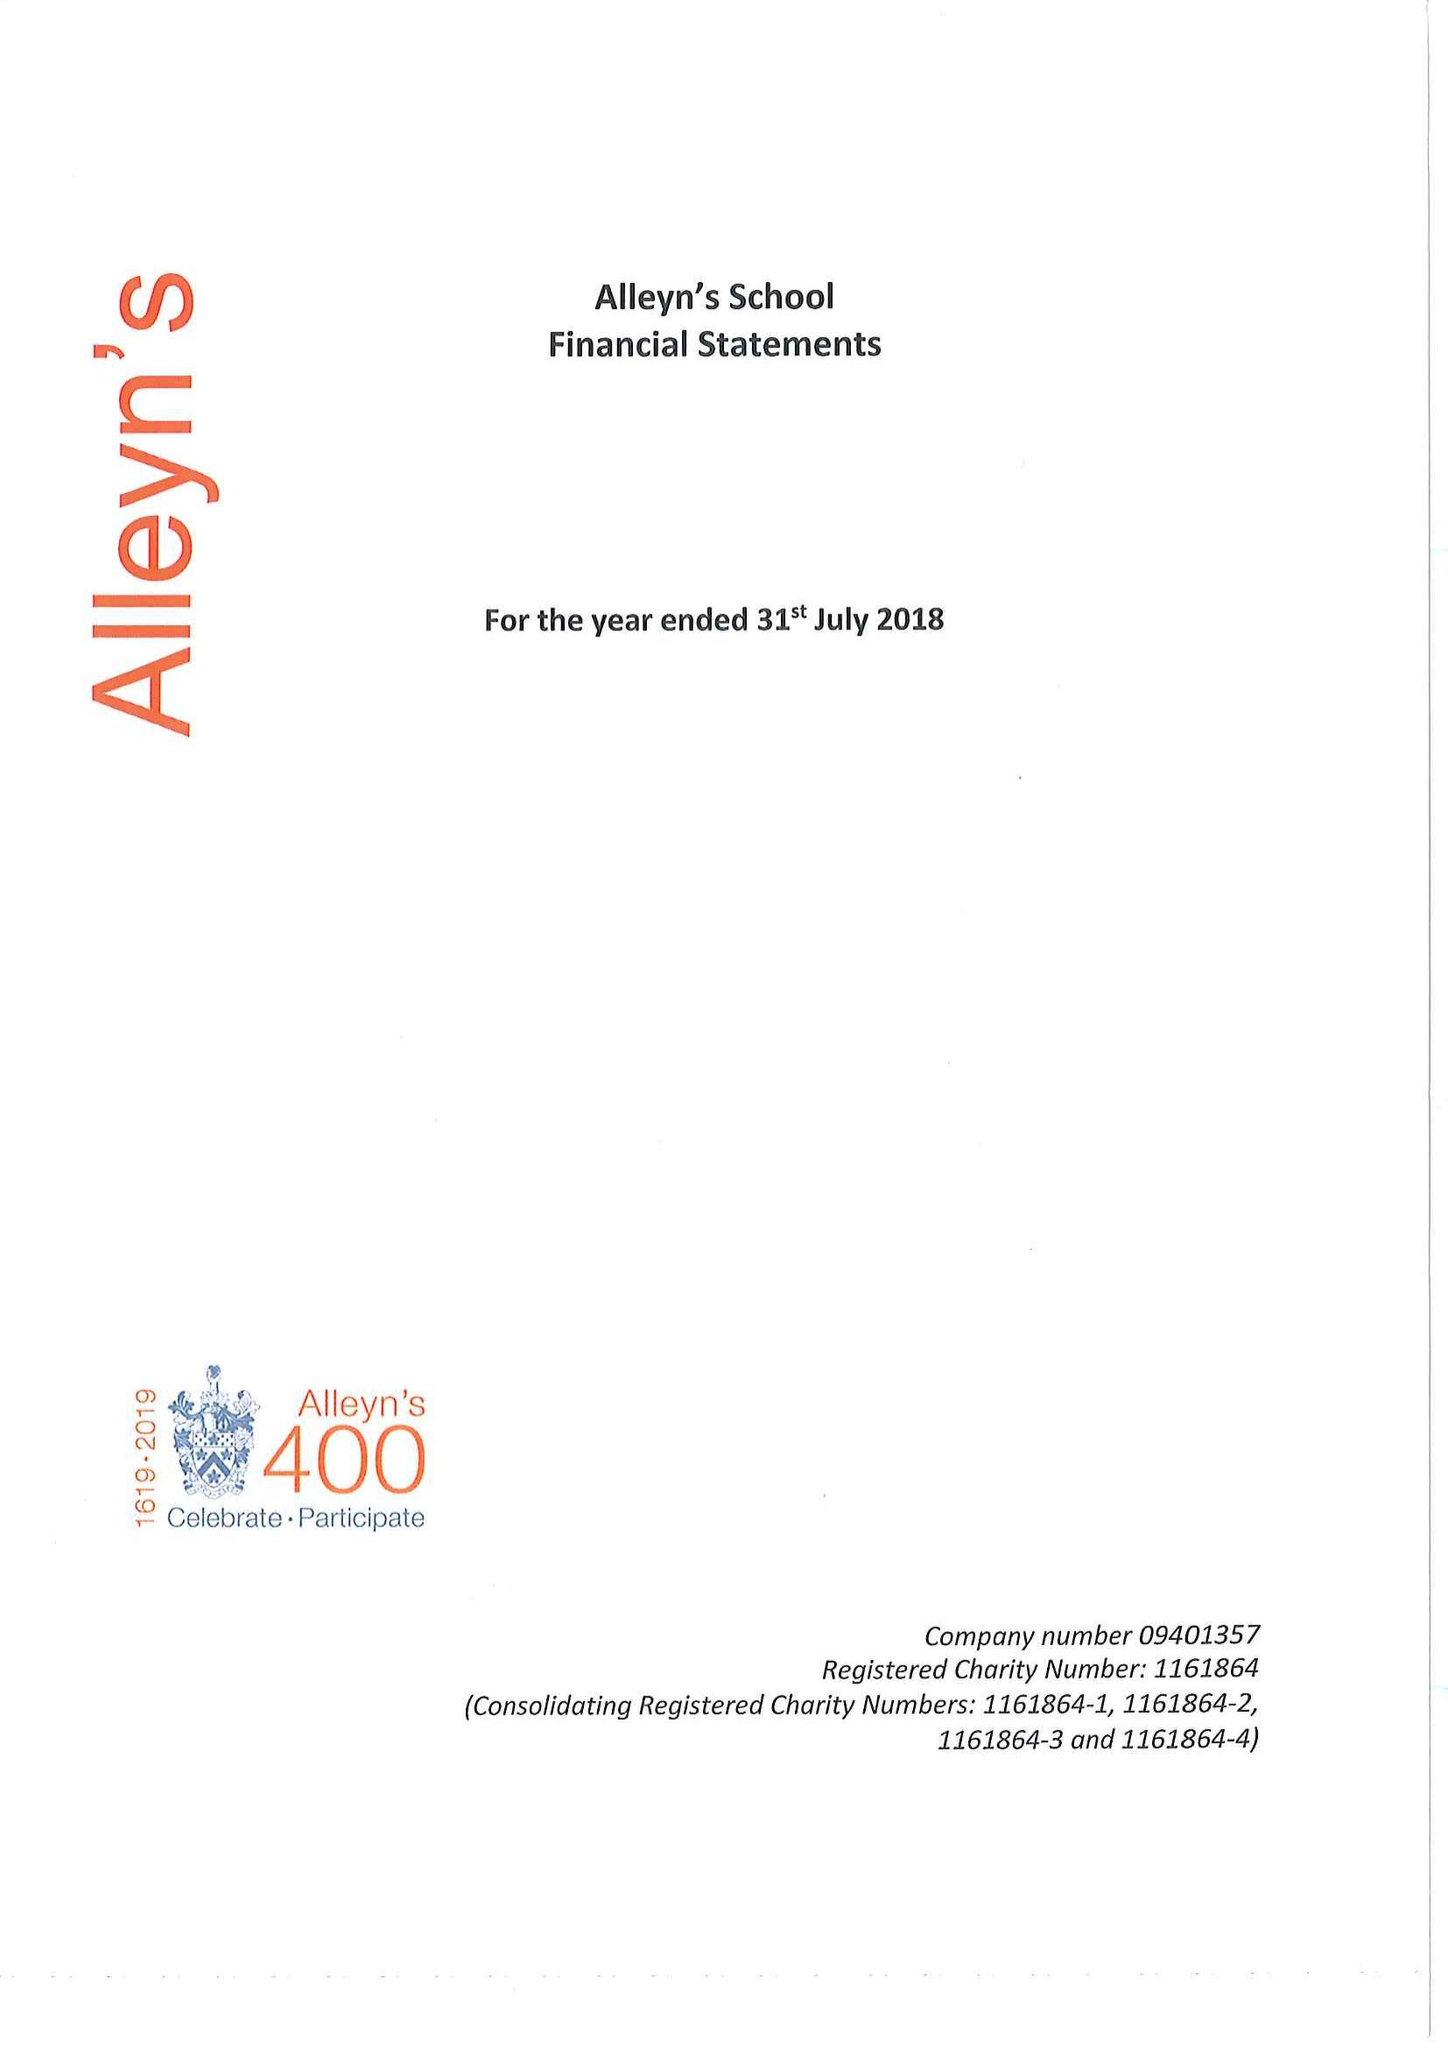What is the value for the report_date?
Answer the question using a single word or phrase. 2018-07-31 